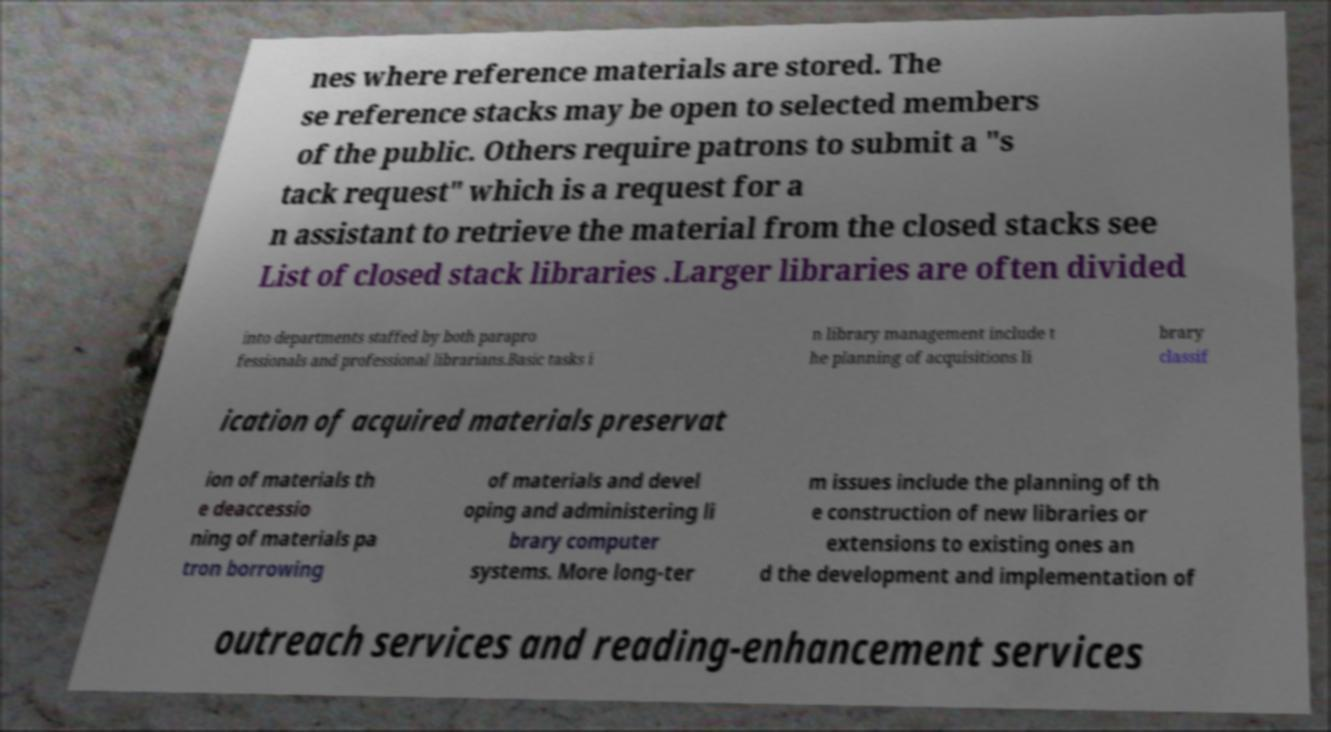Can you accurately transcribe the text from the provided image for me? nes where reference materials are stored. The se reference stacks may be open to selected members of the public. Others require patrons to submit a "s tack request" which is a request for a n assistant to retrieve the material from the closed stacks see List of closed stack libraries .Larger libraries are often divided into departments staffed by both parapro fessionals and professional librarians.Basic tasks i n library management include t he planning of acquisitions li brary classif ication of acquired materials preservat ion of materials th e deaccessio ning of materials pa tron borrowing of materials and devel oping and administering li brary computer systems. More long-ter m issues include the planning of th e construction of new libraries or extensions to existing ones an d the development and implementation of outreach services and reading-enhancement services 